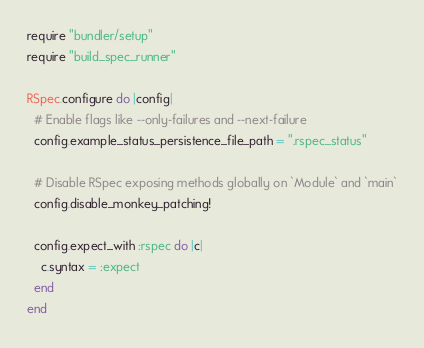Convert code to text. <code><loc_0><loc_0><loc_500><loc_500><_Ruby_>require "bundler/setup"
require "build_spec_runner"

RSpec.configure do |config|
  # Enable flags like --only-failures and --next-failure
  config.example_status_persistence_file_path = ".rspec_status"

  # Disable RSpec exposing methods globally on `Module` and `main`
  config.disable_monkey_patching!

  config.expect_with :rspec do |c|
    c.syntax = :expect
  end
end
</code> 